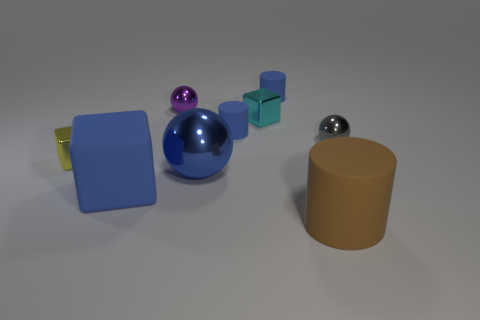Subtract all blue rubber blocks. How many blocks are left? 2 Subtract all green spheres. How many blue cylinders are left? 2 Subtract 2 cylinders. How many cylinders are left? 1 Add 1 small cylinders. How many objects exist? 10 Subtract all blue blocks. How many blocks are left? 2 Subtract all balls. How many objects are left? 6 Subtract 0 yellow cylinders. How many objects are left? 9 Subtract all gray blocks. Subtract all purple spheres. How many blocks are left? 3 Subtract all tiny gray things. Subtract all tiny gray metallic things. How many objects are left? 7 Add 7 small blue cylinders. How many small blue cylinders are left? 9 